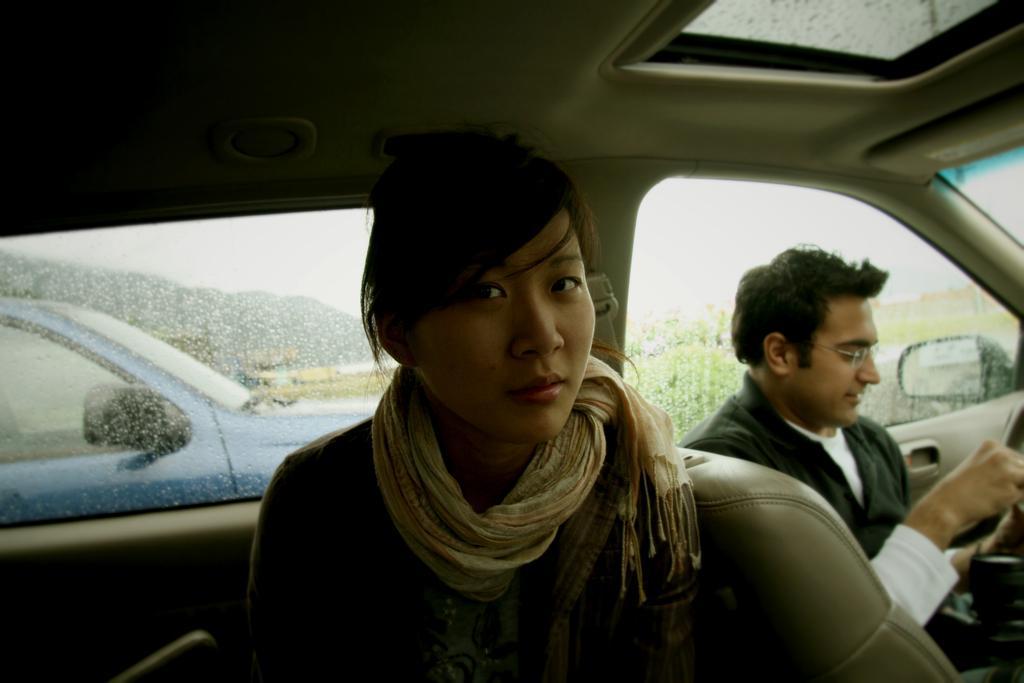Describe this image in one or two sentences. In the picture we can see a woman sitting in a car and a man sitting on another seat in a car, a man is wearing a black shirt with white in it, from the car outside we can see another car which is blue in color and we can also see some hills and grass. 